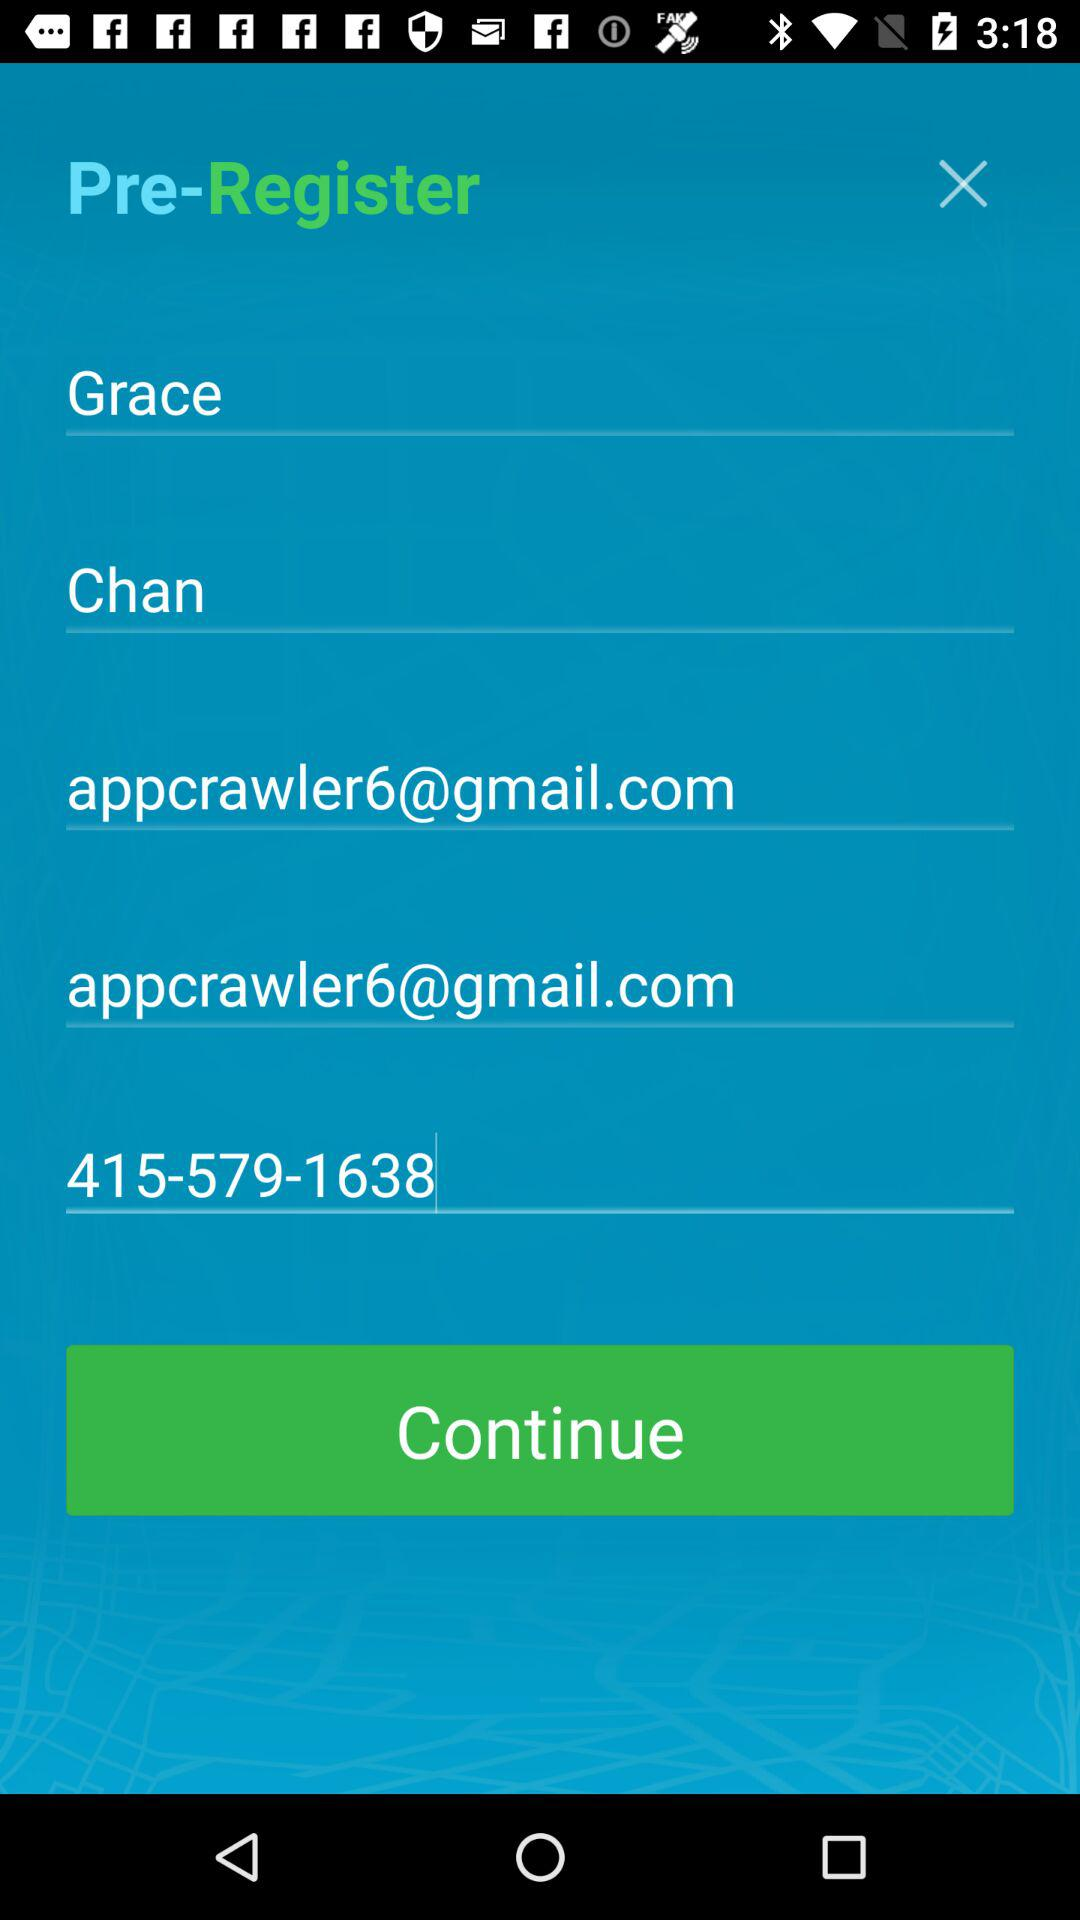How many text inputs are in the pre-registration form?
Answer the question using a single word or phrase. 5 